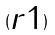<formula> <loc_0><loc_0><loc_500><loc_500>( \begin{matrix} r 1 \end{matrix} )</formula> 